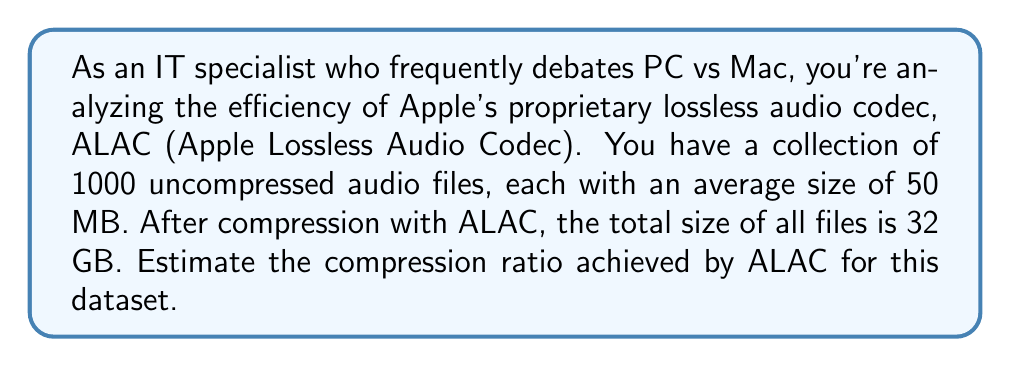Give your solution to this math problem. To solve this problem, we need to follow these steps:

1. Calculate the total size of the uncompressed files:
   $$\text{Uncompressed size} = 1000 \text{ files} \times 50 \text{ MB/file} = 50,000 \text{ MB} = 50 \text{ GB}$$

2. Convert the compressed size to GB:
   $$\text{Compressed size} = 32 \text{ GB}$$

3. Calculate the compression ratio using the formula:
   $$\text{Compression ratio} = \frac{\text{Uncompressed size}}{\text{Compressed size}}$$

4. Substitute the values:
   $$\text{Compression ratio} = \frac{50 \text{ GB}}{32 \text{ GB}} = 1.5625$$

5. To express this as a more common representation, we can write it as:
   $$\text{Compression ratio} = 1.5625:1$$

This means that for every 1.5625 units of uncompressed data, we get 1 unit of compressed data.

To calculate the space savings percentage:
$$\text{Space savings} = (1 - \frac{1}{\text{Compression ratio}}) \times 100\%$$
$$= (1 - \frac{1}{1.5625}) \times 100\% = 36\%$$

This indicates that ALAC has reduced the file sizes by approximately 36% compared to the original uncompressed audio files.
Answer: The compression ratio achieved by ALAC for this dataset is 1.5625:1, or approximately 1.56:1. 